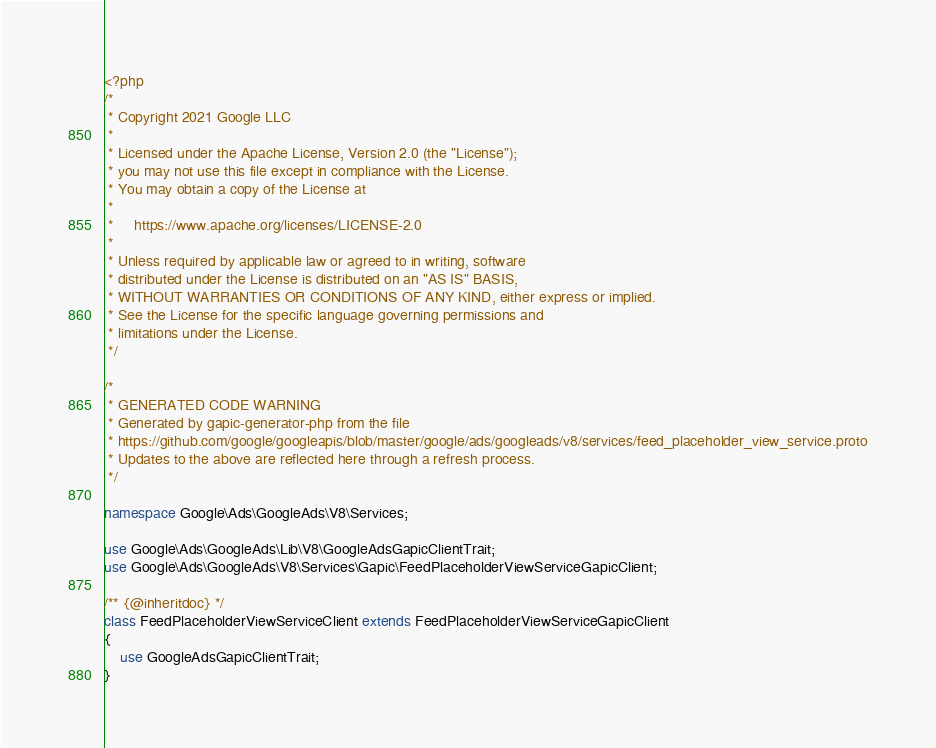<code> <loc_0><loc_0><loc_500><loc_500><_PHP_><?php
/*
 * Copyright 2021 Google LLC
 *
 * Licensed under the Apache License, Version 2.0 (the "License");
 * you may not use this file except in compliance with the License.
 * You may obtain a copy of the License at
 *
 *     https://www.apache.org/licenses/LICENSE-2.0
 *
 * Unless required by applicable law or agreed to in writing, software
 * distributed under the License is distributed on an "AS IS" BASIS,
 * WITHOUT WARRANTIES OR CONDITIONS OF ANY KIND, either express or implied.
 * See the License for the specific language governing permissions and
 * limitations under the License.
 */

/*
 * GENERATED CODE WARNING
 * Generated by gapic-generator-php from the file
 * https://github.com/google/googleapis/blob/master/google/ads/googleads/v8/services/feed_placeholder_view_service.proto
 * Updates to the above are reflected here through a refresh process.
 */

namespace Google\Ads\GoogleAds\V8\Services;

use Google\Ads\GoogleAds\Lib\V8\GoogleAdsGapicClientTrait;
use Google\Ads\GoogleAds\V8\Services\Gapic\FeedPlaceholderViewServiceGapicClient;

/** {@inheritdoc} */
class FeedPlaceholderViewServiceClient extends FeedPlaceholderViewServiceGapicClient
{
    use GoogleAdsGapicClientTrait;
}
</code> 